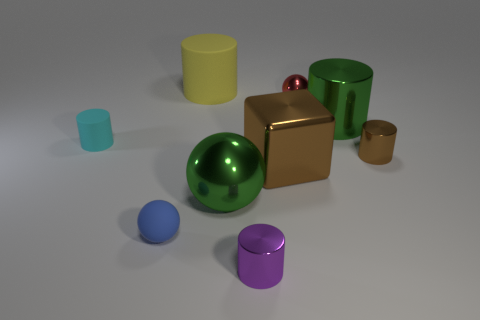Is there a metallic thing of the same size as the green metal cylinder?
Make the answer very short. Yes. Are there fewer purple cylinders left of the purple metal object than small cubes?
Your answer should be very brief. No. Do the blue matte object and the green metallic sphere have the same size?
Offer a very short reply. No. What is the size of the yellow cylinder that is the same material as the blue object?
Your response must be concise. Large. How many things are the same color as the big metal cylinder?
Your answer should be very brief. 1. Is the number of large yellow matte cylinders that are in front of the cube less than the number of yellow matte cylinders that are in front of the tiny blue matte sphere?
Your answer should be very brief. No. Is the shape of the large green metallic thing that is on the right side of the small red object the same as  the small purple object?
Your response must be concise. Yes. Does the big green thing in front of the shiny block have the same material as the red object?
Your answer should be compact. Yes. There is a tiny sphere that is in front of the ball that is right of the large green thing that is on the left side of the tiny purple object; what is its material?
Your answer should be very brief. Rubber. What number of other objects are the same shape as the cyan object?
Your answer should be very brief. 4. 